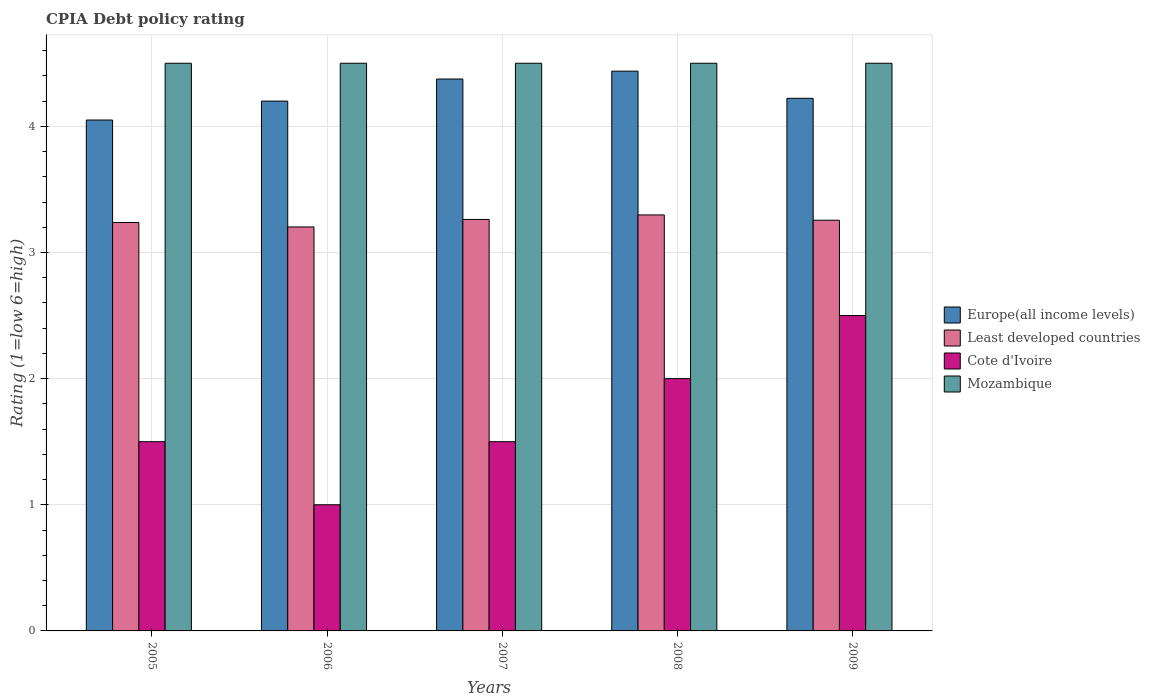How many different coloured bars are there?
Ensure brevity in your answer.  4. Are the number of bars per tick equal to the number of legend labels?
Your answer should be very brief. Yes. Are the number of bars on each tick of the X-axis equal?
Offer a terse response. Yes. How many bars are there on the 1st tick from the left?
Keep it short and to the point. 4. How many bars are there on the 3rd tick from the right?
Provide a succinct answer. 4. What is the CPIA rating in Europe(all income levels) in 2008?
Your answer should be very brief. 4.44. What is the total CPIA rating in Europe(all income levels) in the graph?
Offer a terse response. 21.28. What is the difference between the CPIA rating in Least developed countries in 2005 and that in 2007?
Keep it short and to the point. -0.02. What is the difference between the CPIA rating in Least developed countries in 2009 and the CPIA rating in Mozambique in 2006?
Keep it short and to the point. -1.24. In the year 2007, what is the difference between the CPIA rating in Least developed countries and CPIA rating in Europe(all income levels)?
Offer a terse response. -1.11. In how many years, is the CPIA rating in Least developed countries greater than 3.4?
Your answer should be very brief. 0. What is the ratio of the CPIA rating in Least developed countries in 2005 to that in 2008?
Your answer should be compact. 0.98. Is the CPIA rating in Cote d'Ivoire in 2006 less than that in 2007?
Provide a short and direct response. Yes. What is the difference between the highest and the second highest CPIA rating in Cote d'Ivoire?
Keep it short and to the point. 0.5. What is the difference between the highest and the lowest CPIA rating in Least developed countries?
Provide a short and direct response. 0.1. In how many years, is the CPIA rating in Mozambique greater than the average CPIA rating in Mozambique taken over all years?
Offer a very short reply. 0. What does the 2nd bar from the left in 2005 represents?
Offer a very short reply. Least developed countries. What does the 1st bar from the right in 2009 represents?
Your answer should be very brief. Mozambique. Is it the case that in every year, the sum of the CPIA rating in Mozambique and CPIA rating in Cote d'Ivoire is greater than the CPIA rating in Europe(all income levels)?
Your response must be concise. Yes. What is the difference between two consecutive major ticks on the Y-axis?
Your response must be concise. 1. Does the graph contain any zero values?
Your response must be concise. No. How are the legend labels stacked?
Keep it short and to the point. Vertical. What is the title of the graph?
Make the answer very short. CPIA Debt policy rating. What is the label or title of the X-axis?
Offer a terse response. Years. What is the Rating (1=low 6=high) in Europe(all income levels) in 2005?
Make the answer very short. 4.05. What is the Rating (1=low 6=high) in Least developed countries in 2005?
Your response must be concise. 3.24. What is the Rating (1=low 6=high) in Cote d'Ivoire in 2005?
Your answer should be compact. 1.5. What is the Rating (1=low 6=high) in Mozambique in 2005?
Give a very brief answer. 4.5. What is the Rating (1=low 6=high) in Europe(all income levels) in 2006?
Offer a very short reply. 4.2. What is the Rating (1=low 6=high) of Least developed countries in 2006?
Provide a short and direct response. 3.2. What is the Rating (1=low 6=high) in Mozambique in 2006?
Your answer should be compact. 4.5. What is the Rating (1=low 6=high) of Europe(all income levels) in 2007?
Provide a succinct answer. 4.38. What is the Rating (1=low 6=high) of Least developed countries in 2007?
Your answer should be very brief. 3.26. What is the Rating (1=low 6=high) of Cote d'Ivoire in 2007?
Your answer should be compact. 1.5. What is the Rating (1=low 6=high) of Europe(all income levels) in 2008?
Your response must be concise. 4.44. What is the Rating (1=low 6=high) in Least developed countries in 2008?
Offer a terse response. 3.3. What is the Rating (1=low 6=high) of Mozambique in 2008?
Your response must be concise. 4.5. What is the Rating (1=low 6=high) of Europe(all income levels) in 2009?
Ensure brevity in your answer.  4.22. What is the Rating (1=low 6=high) in Least developed countries in 2009?
Provide a succinct answer. 3.26. What is the Rating (1=low 6=high) of Cote d'Ivoire in 2009?
Your response must be concise. 2.5. What is the Rating (1=low 6=high) in Mozambique in 2009?
Offer a terse response. 4.5. Across all years, what is the maximum Rating (1=low 6=high) of Europe(all income levels)?
Your answer should be very brief. 4.44. Across all years, what is the maximum Rating (1=low 6=high) of Least developed countries?
Provide a succinct answer. 3.3. Across all years, what is the maximum Rating (1=low 6=high) of Cote d'Ivoire?
Your answer should be very brief. 2.5. Across all years, what is the maximum Rating (1=low 6=high) in Mozambique?
Offer a terse response. 4.5. Across all years, what is the minimum Rating (1=low 6=high) of Europe(all income levels)?
Offer a very short reply. 4.05. Across all years, what is the minimum Rating (1=low 6=high) in Least developed countries?
Offer a very short reply. 3.2. What is the total Rating (1=low 6=high) of Europe(all income levels) in the graph?
Your response must be concise. 21.28. What is the total Rating (1=low 6=high) of Least developed countries in the graph?
Your answer should be compact. 16.26. What is the total Rating (1=low 6=high) in Mozambique in the graph?
Give a very brief answer. 22.5. What is the difference between the Rating (1=low 6=high) in Least developed countries in 2005 and that in 2006?
Keep it short and to the point. 0.04. What is the difference between the Rating (1=low 6=high) in Europe(all income levels) in 2005 and that in 2007?
Make the answer very short. -0.33. What is the difference between the Rating (1=low 6=high) in Least developed countries in 2005 and that in 2007?
Your answer should be very brief. -0.02. What is the difference between the Rating (1=low 6=high) in Cote d'Ivoire in 2005 and that in 2007?
Your answer should be very brief. 0. What is the difference between the Rating (1=low 6=high) of Europe(all income levels) in 2005 and that in 2008?
Your answer should be very brief. -0.39. What is the difference between the Rating (1=low 6=high) in Least developed countries in 2005 and that in 2008?
Offer a terse response. -0.06. What is the difference between the Rating (1=low 6=high) of Europe(all income levels) in 2005 and that in 2009?
Your answer should be very brief. -0.17. What is the difference between the Rating (1=low 6=high) of Least developed countries in 2005 and that in 2009?
Give a very brief answer. -0.02. What is the difference between the Rating (1=low 6=high) of Cote d'Ivoire in 2005 and that in 2009?
Keep it short and to the point. -1. What is the difference between the Rating (1=low 6=high) in Mozambique in 2005 and that in 2009?
Offer a terse response. 0. What is the difference between the Rating (1=low 6=high) of Europe(all income levels) in 2006 and that in 2007?
Your answer should be very brief. -0.17. What is the difference between the Rating (1=low 6=high) in Least developed countries in 2006 and that in 2007?
Offer a terse response. -0.06. What is the difference between the Rating (1=low 6=high) of Mozambique in 2006 and that in 2007?
Offer a terse response. 0. What is the difference between the Rating (1=low 6=high) of Europe(all income levels) in 2006 and that in 2008?
Ensure brevity in your answer.  -0.24. What is the difference between the Rating (1=low 6=high) of Least developed countries in 2006 and that in 2008?
Provide a short and direct response. -0.1. What is the difference between the Rating (1=low 6=high) of Cote d'Ivoire in 2006 and that in 2008?
Your answer should be very brief. -1. What is the difference between the Rating (1=low 6=high) of Mozambique in 2006 and that in 2008?
Provide a short and direct response. 0. What is the difference between the Rating (1=low 6=high) of Europe(all income levels) in 2006 and that in 2009?
Offer a terse response. -0.02. What is the difference between the Rating (1=low 6=high) in Least developed countries in 2006 and that in 2009?
Make the answer very short. -0.05. What is the difference between the Rating (1=low 6=high) in Europe(all income levels) in 2007 and that in 2008?
Provide a succinct answer. -0.06. What is the difference between the Rating (1=low 6=high) in Least developed countries in 2007 and that in 2008?
Provide a short and direct response. -0.04. What is the difference between the Rating (1=low 6=high) in Cote d'Ivoire in 2007 and that in 2008?
Provide a short and direct response. -0.5. What is the difference between the Rating (1=low 6=high) of Europe(all income levels) in 2007 and that in 2009?
Offer a very short reply. 0.15. What is the difference between the Rating (1=low 6=high) of Least developed countries in 2007 and that in 2009?
Provide a succinct answer. 0.01. What is the difference between the Rating (1=low 6=high) in Cote d'Ivoire in 2007 and that in 2009?
Offer a terse response. -1. What is the difference between the Rating (1=low 6=high) of Mozambique in 2007 and that in 2009?
Offer a very short reply. 0. What is the difference between the Rating (1=low 6=high) in Europe(all income levels) in 2008 and that in 2009?
Give a very brief answer. 0.22. What is the difference between the Rating (1=low 6=high) in Least developed countries in 2008 and that in 2009?
Offer a very short reply. 0.04. What is the difference between the Rating (1=low 6=high) in Europe(all income levels) in 2005 and the Rating (1=low 6=high) in Least developed countries in 2006?
Provide a succinct answer. 0.85. What is the difference between the Rating (1=low 6=high) of Europe(all income levels) in 2005 and the Rating (1=low 6=high) of Cote d'Ivoire in 2006?
Your response must be concise. 3.05. What is the difference between the Rating (1=low 6=high) in Europe(all income levels) in 2005 and the Rating (1=low 6=high) in Mozambique in 2006?
Keep it short and to the point. -0.45. What is the difference between the Rating (1=low 6=high) of Least developed countries in 2005 and the Rating (1=low 6=high) of Cote d'Ivoire in 2006?
Provide a short and direct response. 2.24. What is the difference between the Rating (1=low 6=high) of Least developed countries in 2005 and the Rating (1=low 6=high) of Mozambique in 2006?
Offer a terse response. -1.26. What is the difference between the Rating (1=low 6=high) in Cote d'Ivoire in 2005 and the Rating (1=low 6=high) in Mozambique in 2006?
Keep it short and to the point. -3. What is the difference between the Rating (1=low 6=high) in Europe(all income levels) in 2005 and the Rating (1=low 6=high) in Least developed countries in 2007?
Ensure brevity in your answer.  0.79. What is the difference between the Rating (1=low 6=high) of Europe(all income levels) in 2005 and the Rating (1=low 6=high) of Cote d'Ivoire in 2007?
Make the answer very short. 2.55. What is the difference between the Rating (1=low 6=high) in Europe(all income levels) in 2005 and the Rating (1=low 6=high) in Mozambique in 2007?
Make the answer very short. -0.45. What is the difference between the Rating (1=low 6=high) of Least developed countries in 2005 and the Rating (1=low 6=high) of Cote d'Ivoire in 2007?
Give a very brief answer. 1.74. What is the difference between the Rating (1=low 6=high) in Least developed countries in 2005 and the Rating (1=low 6=high) in Mozambique in 2007?
Your answer should be compact. -1.26. What is the difference between the Rating (1=low 6=high) of Cote d'Ivoire in 2005 and the Rating (1=low 6=high) of Mozambique in 2007?
Offer a very short reply. -3. What is the difference between the Rating (1=low 6=high) of Europe(all income levels) in 2005 and the Rating (1=low 6=high) of Least developed countries in 2008?
Ensure brevity in your answer.  0.75. What is the difference between the Rating (1=low 6=high) in Europe(all income levels) in 2005 and the Rating (1=low 6=high) in Cote d'Ivoire in 2008?
Offer a terse response. 2.05. What is the difference between the Rating (1=low 6=high) in Europe(all income levels) in 2005 and the Rating (1=low 6=high) in Mozambique in 2008?
Make the answer very short. -0.45. What is the difference between the Rating (1=low 6=high) of Least developed countries in 2005 and the Rating (1=low 6=high) of Cote d'Ivoire in 2008?
Keep it short and to the point. 1.24. What is the difference between the Rating (1=low 6=high) of Least developed countries in 2005 and the Rating (1=low 6=high) of Mozambique in 2008?
Your answer should be compact. -1.26. What is the difference between the Rating (1=low 6=high) of Cote d'Ivoire in 2005 and the Rating (1=low 6=high) of Mozambique in 2008?
Your response must be concise. -3. What is the difference between the Rating (1=low 6=high) in Europe(all income levels) in 2005 and the Rating (1=low 6=high) in Least developed countries in 2009?
Provide a succinct answer. 0.79. What is the difference between the Rating (1=low 6=high) of Europe(all income levels) in 2005 and the Rating (1=low 6=high) of Cote d'Ivoire in 2009?
Offer a very short reply. 1.55. What is the difference between the Rating (1=low 6=high) of Europe(all income levels) in 2005 and the Rating (1=low 6=high) of Mozambique in 2009?
Make the answer very short. -0.45. What is the difference between the Rating (1=low 6=high) of Least developed countries in 2005 and the Rating (1=low 6=high) of Cote d'Ivoire in 2009?
Ensure brevity in your answer.  0.74. What is the difference between the Rating (1=low 6=high) in Least developed countries in 2005 and the Rating (1=low 6=high) in Mozambique in 2009?
Provide a short and direct response. -1.26. What is the difference between the Rating (1=low 6=high) of Europe(all income levels) in 2006 and the Rating (1=low 6=high) of Least developed countries in 2007?
Ensure brevity in your answer.  0.94. What is the difference between the Rating (1=low 6=high) in Least developed countries in 2006 and the Rating (1=low 6=high) in Cote d'Ivoire in 2007?
Give a very brief answer. 1.7. What is the difference between the Rating (1=low 6=high) of Least developed countries in 2006 and the Rating (1=low 6=high) of Mozambique in 2007?
Keep it short and to the point. -1.3. What is the difference between the Rating (1=low 6=high) in Europe(all income levels) in 2006 and the Rating (1=low 6=high) in Least developed countries in 2008?
Keep it short and to the point. 0.9. What is the difference between the Rating (1=low 6=high) in Europe(all income levels) in 2006 and the Rating (1=low 6=high) in Cote d'Ivoire in 2008?
Your answer should be very brief. 2.2. What is the difference between the Rating (1=low 6=high) of Europe(all income levels) in 2006 and the Rating (1=low 6=high) of Mozambique in 2008?
Keep it short and to the point. -0.3. What is the difference between the Rating (1=low 6=high) in Least developed countries in 2006 and the Rating (1=low 6=high) in Cote d'Ivoire in 2008?
Keep it short and to the point. 1.2. What is the difference between the Rating (1=low 6=high) in Least developed countries in 2006 and the Rating (1=low 6=high) in Mozambique in 2008?
Provide a succinct answer. -1.3. What is the difference between the Rating (1=low 6=high) in Europe(all income levels) in 2006 and the Rating (1=low 6=high) in Least developed countries in 2009?
Offer a very short reply. 0.94. What is the difference between the Rating (1=low 6=high) in Europe(all income levels) in 2006 and the Rating (1=low 6=high) in Cote d'Ivoire in 2009?
Offer a very short reply. 1.7. What is the difference between the Rating (1=low 6=high) in Europe(all income levels) in 2006 and the Rating (1=low 6=high) in Mozambique in 2009?
Make the answer very short. -0.3. What is the difference between the Rating (1=low 6=high) in Least developed countries in 2006 and the Rating (1=low 6=high) in Cote d'Ivoire in 2009?
Keep it short and to the point. 0.7. What is the difference between the Rating (1=low 6=high) in Least developed countries in 2006 and the Rating (1=low 6=high) in Mozambique in 2009?
Give a very brief answer. -1.3. What is the difference between the Rating (1=low 6=high) in Europe(all income levels) in 2007 and the Rating (1=low 6=high) in Least developed countries in 2008?
Offer a very short reply. 1.08. What is the difference between the Rating (1=low 6=high) in Europe(all income levels) in 2007 and the Rating (1=low 6=high) in Cote d'Ivoire in 2008?
Your answer should be very brief. 2.38. What is the difference between the Rating (1=low 6=high) in Europe(all income levels) in 2007 and the Rating (1=low 6=high) in Mozambique in 2008?
Ensure brevity in your answer.  -0.12. What is the difference between the Rating (1=low 6=high) of Least developed countries in 2007 and the Rating (1=low 6=high) of Cote d'Ivoire in 2008?
Ensure brevity in your answer.  1.26. What is the difference between the Rating (1=low 6=high) of Least developed countries in 2007 and the Rating (1=low 6=high) of Mozambique in 2008?
Offer a very short reply. -1.24. What is the difference between the Rating (1=low 6=high) in Cote d'Ivoire in 2007 and the Rating (1=low 6=high) in Mozambique in 2008?
Provide a short and direct response. -3. What is the difference between the Rating (1=low 6=high) of Europe(all income levels) in 2007 and the Rating (1=low 6=high) of Least developed countries in 2009?
Keep it short and to the point. 1.12. What is the difference between the Rating (1=low 6=high) of Europe(all income levels) in 2007 and the Rating (1=low 6=high) of Cote d'Ivoire in 2009?
Make the answer very short. 1.88. What is the difference between the Rating (1=low 6=high) in Europe(all income levels) in 2007 and the Rating (1=low 6=high) in Mozambique in 2009?
Your response must be concise. -0.12. What is the difference between the Rating (1=low 6=high) of Least developed countries in 2007 and the Rating (1=low 6=high) of Cote d'Ivoire in 2009?
Provide a short and direct response. 0.76. What is the difference between the Rating (1=low 6=high) of Least developed countries in 2007 and the Rating (1=low 6=high) of Mozambique in 2009?
Offer a terse response. -1.24. What is the difference between the Rating (1=low 6=high) of Europe(all income levels) in 2008 and the Rating (1=low 6=high) of Least developed countries in 2009?
Offer a terse response. 1.18. What is the difference between the Rating (1=low 6=high) of Europe(all income levels) in 2008 and the Rating (1=low 6=high) of Cote d'Ivoire in 2009?
Your answer should be very brief. 1.94. What is the difference between the Rating (1=low 6=high) in Europe(all income levels) in 2008 and the Rating (1=low 6=high) in Mozambique in 2009?
Provide a succinct answer. -0.06. What is the difference between the Rating (1=low 6=high) in Least developed countries in 2008 and the Rating (1=low 6=high) in Cote d'Ivoire in 2009?
Provide a succinct answer. 0.8. What is the difference between the Rating (1=low 6=high) in Least developed countries in 2008 and the Rating (1=low 6=high) in Mozambique in 2009?
Make the answer very short. -1.2. What is the difference between the Rating (1=low 6=high) in Cote d'Ivoire in 2008 and the Rating (1=low 6=high) in Mozambique in 2009?
Ensure brevity in your answer.  -2.5. What is the average Rating (1=low 6=high) in Europe(all income levels) per year?
Make the answer very short. 4.26. What is the average Rating (1=low 6=high) of Least developed countries per year?
Give a very brief answer. 3.25. What is the average Rating (1=low 6=high) in Cote d'Ivoire per year?
Give a very brief answer. 1.7. In the year 2005, what is the difference between the Rating (1=low 6=high) of Europe(all income levels) and Rating (1=low 6=high) of Least developed countries?
Give a very brief answer. 0.81. In the year 2005, what is the difference between the Rating (1=low 6=high) of Europe(all income levels) and Rating (1=low 6=high) of Cote d'Ivoire?
Offer a very short reply. 2.55. In the year 2005, what is the difference between the Rating (1=low 6=high) of Europe(all income levels) and Rating (1=low 6=high) of Mozambique?
Provide a succinct answer. -0.45. In the year 2005, what is the difference between the Rating (1=low 6=high) of Least developed countries and Rating (1=low 6=high) of Cote d'Ivoire?
Keep it short and to the point. 1.74. In the year 2005, what is the difference between the Rating (1=low 6=high) of Least developed countries and Rating (1=low 6=high) of Mozambique?
Provide a succinct answer. -1.26. In the year 2006, what is the difference between the Rating (1=low 6=high) of Europe(all income levels) and Rating (1=low 6=high) of Least developed countries?
Make the answer very short. 1. In the year 2006, what is the difference between the Rating (1=low 6=high) of Europe(all income levels) and Rating (1=low 6=high) of Cote d'Ivoire?
Offer a terse response. 3.2. In the year 2006, what is the difference between the Rating (1=low 6=high) of Least developed countries and Rating (1=low 6=high) of Cote d'Ivoire?
Provide a succinct answer. 2.2. In the year 2006, what is the difference between the Rating (1=low 6=high) in Least developed countries and Rating (1=low 6=high) in Mozambique?
Give a very brief answer. -1.3. In the year 2007, what is the difference between the Rating (1=low 6=high) in Europe(all income levels) and Rating (1=low 6=high) in Least developed countries?
Your response must be concise. 1.11. In the year 2007, what is the difference between the Rating (1=low 6=high) in Europe(all income levels) and Rating (1=low 6=high) in Cote d'Ivoire?
Your answer should be compact. 2.88. In the year 2007, what is the difference between the Rating (1=low 6=high) of Europe(all income levels) and Rating (1=low 6=high) of Mozambique?
Your answer should be compact. -0.12. In the year 2007, what is the difference between the Rating (1=low 6=high) of Least developed countries and Rating (1=low 6=high) of Cote d'Ivoire?
Make the answer very short. 1.76. In the year 2007, what is the difference between the Rating (1=low 6=high) in Least developed countries and Rating (1=low 6=high) in Mozambique?
Your answer should be very brief. -1.24. In the year 2008, what is the difference between the Rating (1=low 6=high) in Europe(all income levels) and Rating (1=low 6=high) in Least developed countries?
Make the answer very short. 1.14. In the year 2008, what is the difference between the Rating (1=low 6=high) of Europe(all income levels) and Rating (1=low 6=high) of Cote d'Ivoire?
Make the answer very short. 2.44. In the year 2008, what is the difference between the Rating (1=low 6=high) in Europe(all income levels) and Rating (1=low 6=high) in Mozambique?
Your answer should be very brief. -0.06. In the year 2008, what is the difference between the Rating (1=low 6=high) of Least developed countries and Rating (1=low 6=high) of Cote d'Ivoire?
Your response must be concise. 1.3. In the year 2008, what is the difference between the Rating (1=low 6=high) in Least developed countries and Rating (1=low 6=high) in Mozambique?
Offer a terse response. -1.2. In the year 2008, what is the difference between the Rating (1=low 6=high) in Cote d'Ivoire and Rating (1=low 6=high) in Mozambique?
Keep it short and to the point. -2.5. In the year 2009, what is the difference between the Rating (1=low 6=high) in Europe(all income levels) and Rating (1=low 6=high) in Least developed countries?
Offer a terse response. 0.97. In the year 2009, what is the difference between the Rating (1=low 6=high) of Europe(all income levels) and Rating (1=low 6=high) of Cote d'Ivoire?
Ensure brevity in your answer.  1.72. In the year 2009, what is the difference between the Rating (1=low 6=high) of Europe(all income levels) and Rating (1=low 6=high) of Mozambique?
Ensure brevity in your answer.  -0.28. In the year 2009, what is the difference between the Rating (1=low 6=high) in Least developed countries and Rating (1=low 6=high) in Cote d'Ivoire?
Offer a terse response. 0.76. In the year 2009, what is the difference between the Rating (1=low 6=high) in Least developed countries and Rating (1=low 6=high) in Mozambique?
Offer a terse response. -1.24. In the year 2009, what is the difference between the Rating (1=low 6=high) in Cote d'Ivoire and Rating (1=low 6=high) in Mozambique?
Your response must be concise. -2. What is the ratio of the Rating (1=low 6=high) in Europe(all income levels) in 2005 to that in 2007?
Your answer should be very brief. 0.93. What is the ratio of the Rating (1=low 6=high) in Least developed countries in 2005 to that in 2007?
Your response must be concise. 0.99. What is the ratio of the Rating (1=low 6=high) of Europe(all income levels) in 2005 to that in 2008?
Offer a terse response. 0.91. What is the ratio of the Rating (1=low 6=high) in Least developed countries in 2005 to that in 2008?
Make the answer very short. 0.98. What is the ratio of the Rating (1=low 6=high) of Cote d'Ivoire in 2005 to that in 2008?
Your response must be concise. 0.75. What is the ratio of the Rating (1=low 6=high) of Europe(all income levels) in 2005 to that in 2009?
Give a very brief answer. 0.96. What is the ratio of the Rating (1=low 6=high) of Cote d'Ivoire in 2005 to that in 2009?
Keep it short and to the point. 0.6. What is the ratio of the Rating (1=low 6=high) of Mozambique in 2005 to that in 2009?
Offer a very short reply. 1. What is the ratio of the Rating (1=low 6=high) in Least developed countries in 2006 to that in 2007?
Your response must be concise. 0.98. What is the ratio of the Rating (1=low 6=high) of Cote d'Ivoire in 2006 to that in 2007?
Offer a very short reply. 0.67. What is the ratio of the Rating (1=low 6=high) of Mozambique in 2006 to that in 2007?
Make the answer very short. 1. What is the ratio of the Rating (1=low 6=high) of Europe(all income levels) in 2006 to that in 2008?
Offer a very short reply. 0.95. What is the ratio of the Rating (1=low 6=high) of Least developed countries in 2006 to that in 2008?
Provide a short and direct response. 0.97. What is the ratio of the Rating (1=low 6=high) of Least developed countries in 2006 to that in 2009?
Ensure brevity in your answer.  0.98. What is the ratio of the Rating (1=low 6=high) in Europe(all income levels) in 2007 to that in 2008?
Provide a succinct answer. 0.99. What is the ratio of the Rating (1=low 6=high) of Least developed countries in 2007 to that in 2008?
Ensure brevity in your answer.  0.99. What is the ratio of the Rating (1=low 6=high) in Cote d'Ivoire in 2007 to that in 2008?
Your answer should be very brief. 0.75. What is the ratio of the Rating (1=low 6=high) in Mozambique in 2007 to that in 2008?
Provide a succinct answer. 1. What is the ratio of the Rating (1=low 6=high) of Europe(all income levels) in 2007 to that in 2009?
Give a very brief answer. 1.04. What is the ratio of the Rating (1=low 6=high) in Least developed countries in 2007 to that in 2009?
Your answer should be compact. 1. What is the ratio of the Rating (1=low 6=high) in Cote d'Ivoire in 2007 to that in 2009?
Provide a succinct answer. 0.6. What is the ratio of the Rating (1=low 6=high) of Europe(all income levels) in 2008 to that in 2009?
Make the answer very short. 1.05. What is the ratio of the Rating (1=low 6=high) of Least developed countries in 2008 to that in 2009?
Provide a succinct answer. 1.01. What is the ratio of the Rating (1=low 6=high) in Cote d'Ivoire in 2008 to that in 2009?
Your answer should be compact. 0.8. What is the difference between the highest and the second highest Rating (1=low 6=high) in Europe(all income levels)?
Provide a short and direct response. 0.06. What is the difference between the highest and the second highest Rating (1=low 6=high) of Least developed countries?
Ensure brevity in your answer.  0.04. What is the difference between the highest and the second highest Rating (1=low 6=high) in Cote d'Ivoire?
Provide a succinct answer. 0.5. What is the difference between the highest and the lowest Rating (1=low 6=high) of Europe(all income levels)?
Offer a terse response. 0.39. What is the difference between the highest and the lowest Rating (1=low 6=high) in Least developed countries?
Your answer should be compact. 0.1. What is the difference between the highest and the lowest Rating (1=low 6=high) in Cote d'Ivoire?
Your response must be concise. 1.5. What is the difference between the highest and the lowest Rating (1=low 6=high) in Mozambique?
Offer a terse response. 0. 